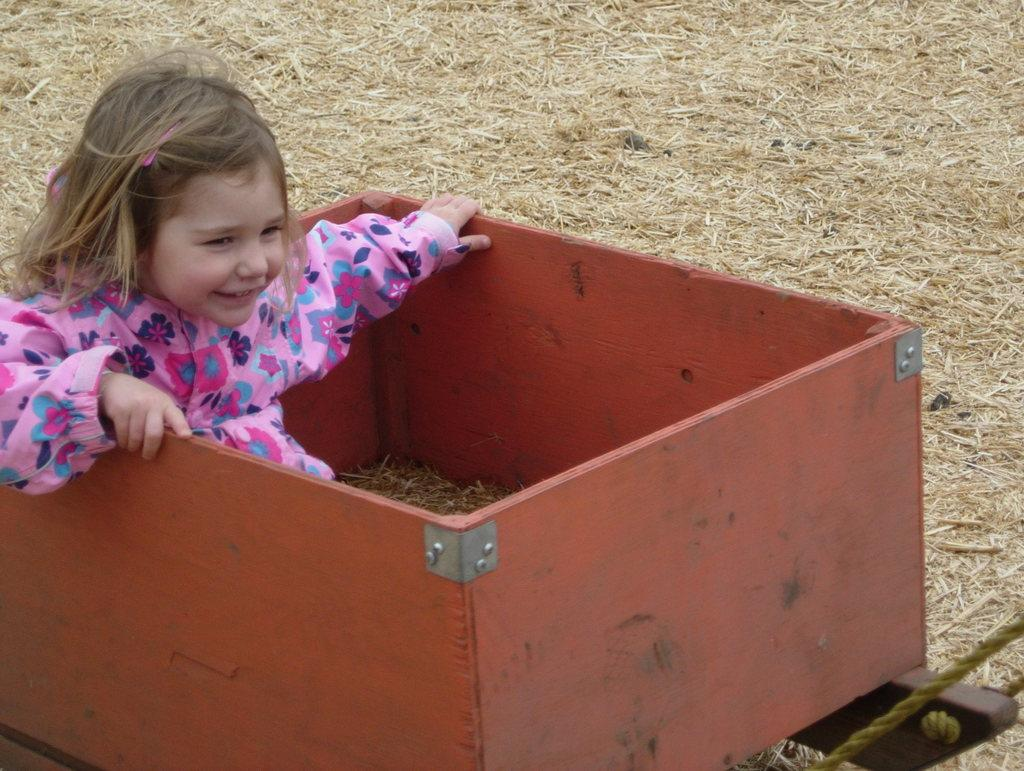Who is the main subject in the image? There is a girl in the image. What might the girl be doing in the image? The girl might be sitting in a box. What is the girl wearing in the image? The girl is wearing a pink dress. What other object can be seen in the image? There is a rope visible in the image. What type of office furniture can be seen in the image? There is no office furniture present in the image. How does the girl's mind appear in the image? The image does not show the girl's mind; it only shows her physical appearance and actions. 